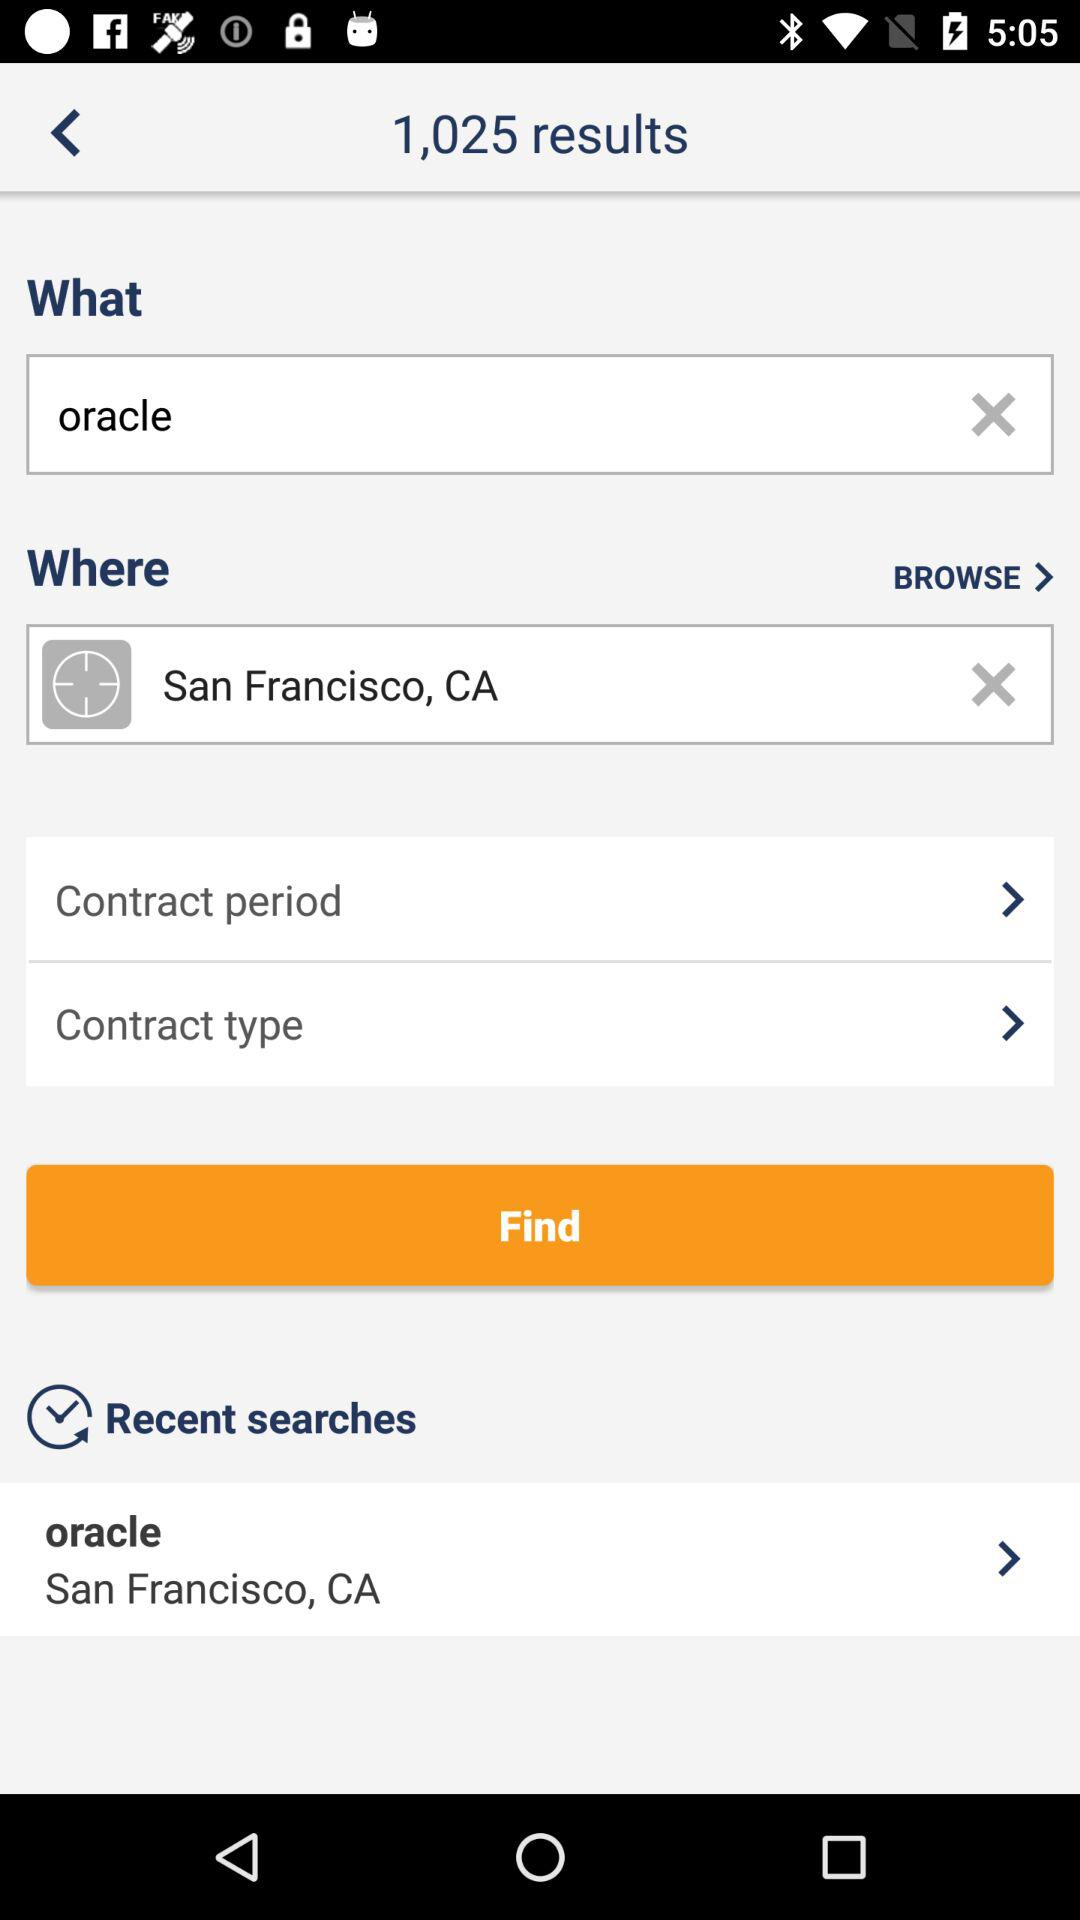For what location is "oracle" being searched? "oracle" is being searched for the San Francisco, CA location. 